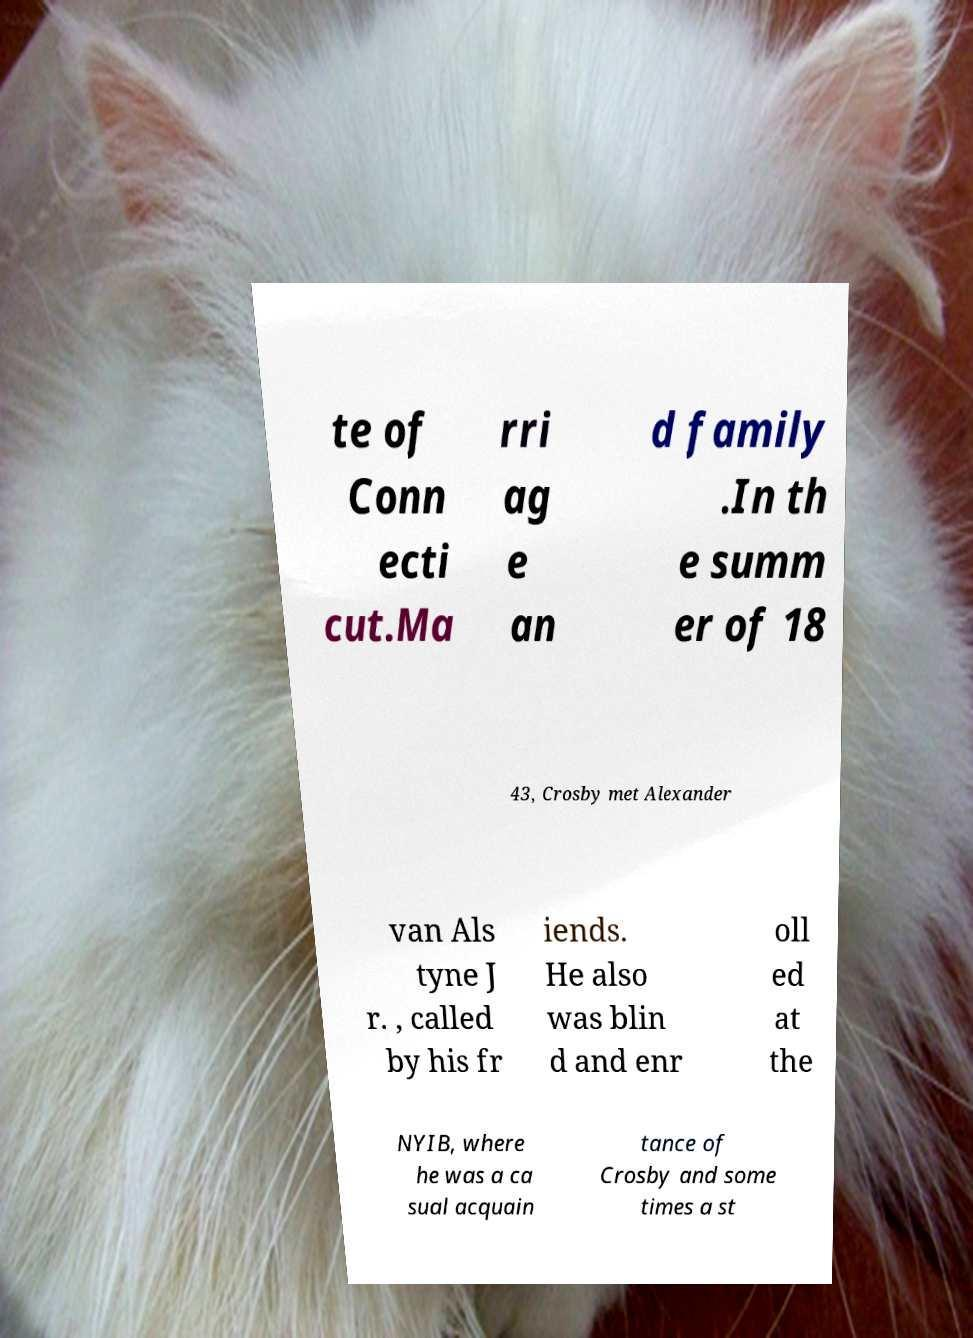I need the written content from this picture converted into text. Can you do that? te of Conn ecti cut.Ma rri ag e an d family .In th e summ er of 18 43, Crosby met Alexander van Als tyne J r. , called by his fr iends. He also was blin d and enr oll ed at the NYIB, where he was a ca sual acquain tance of Crosby and some times a st 